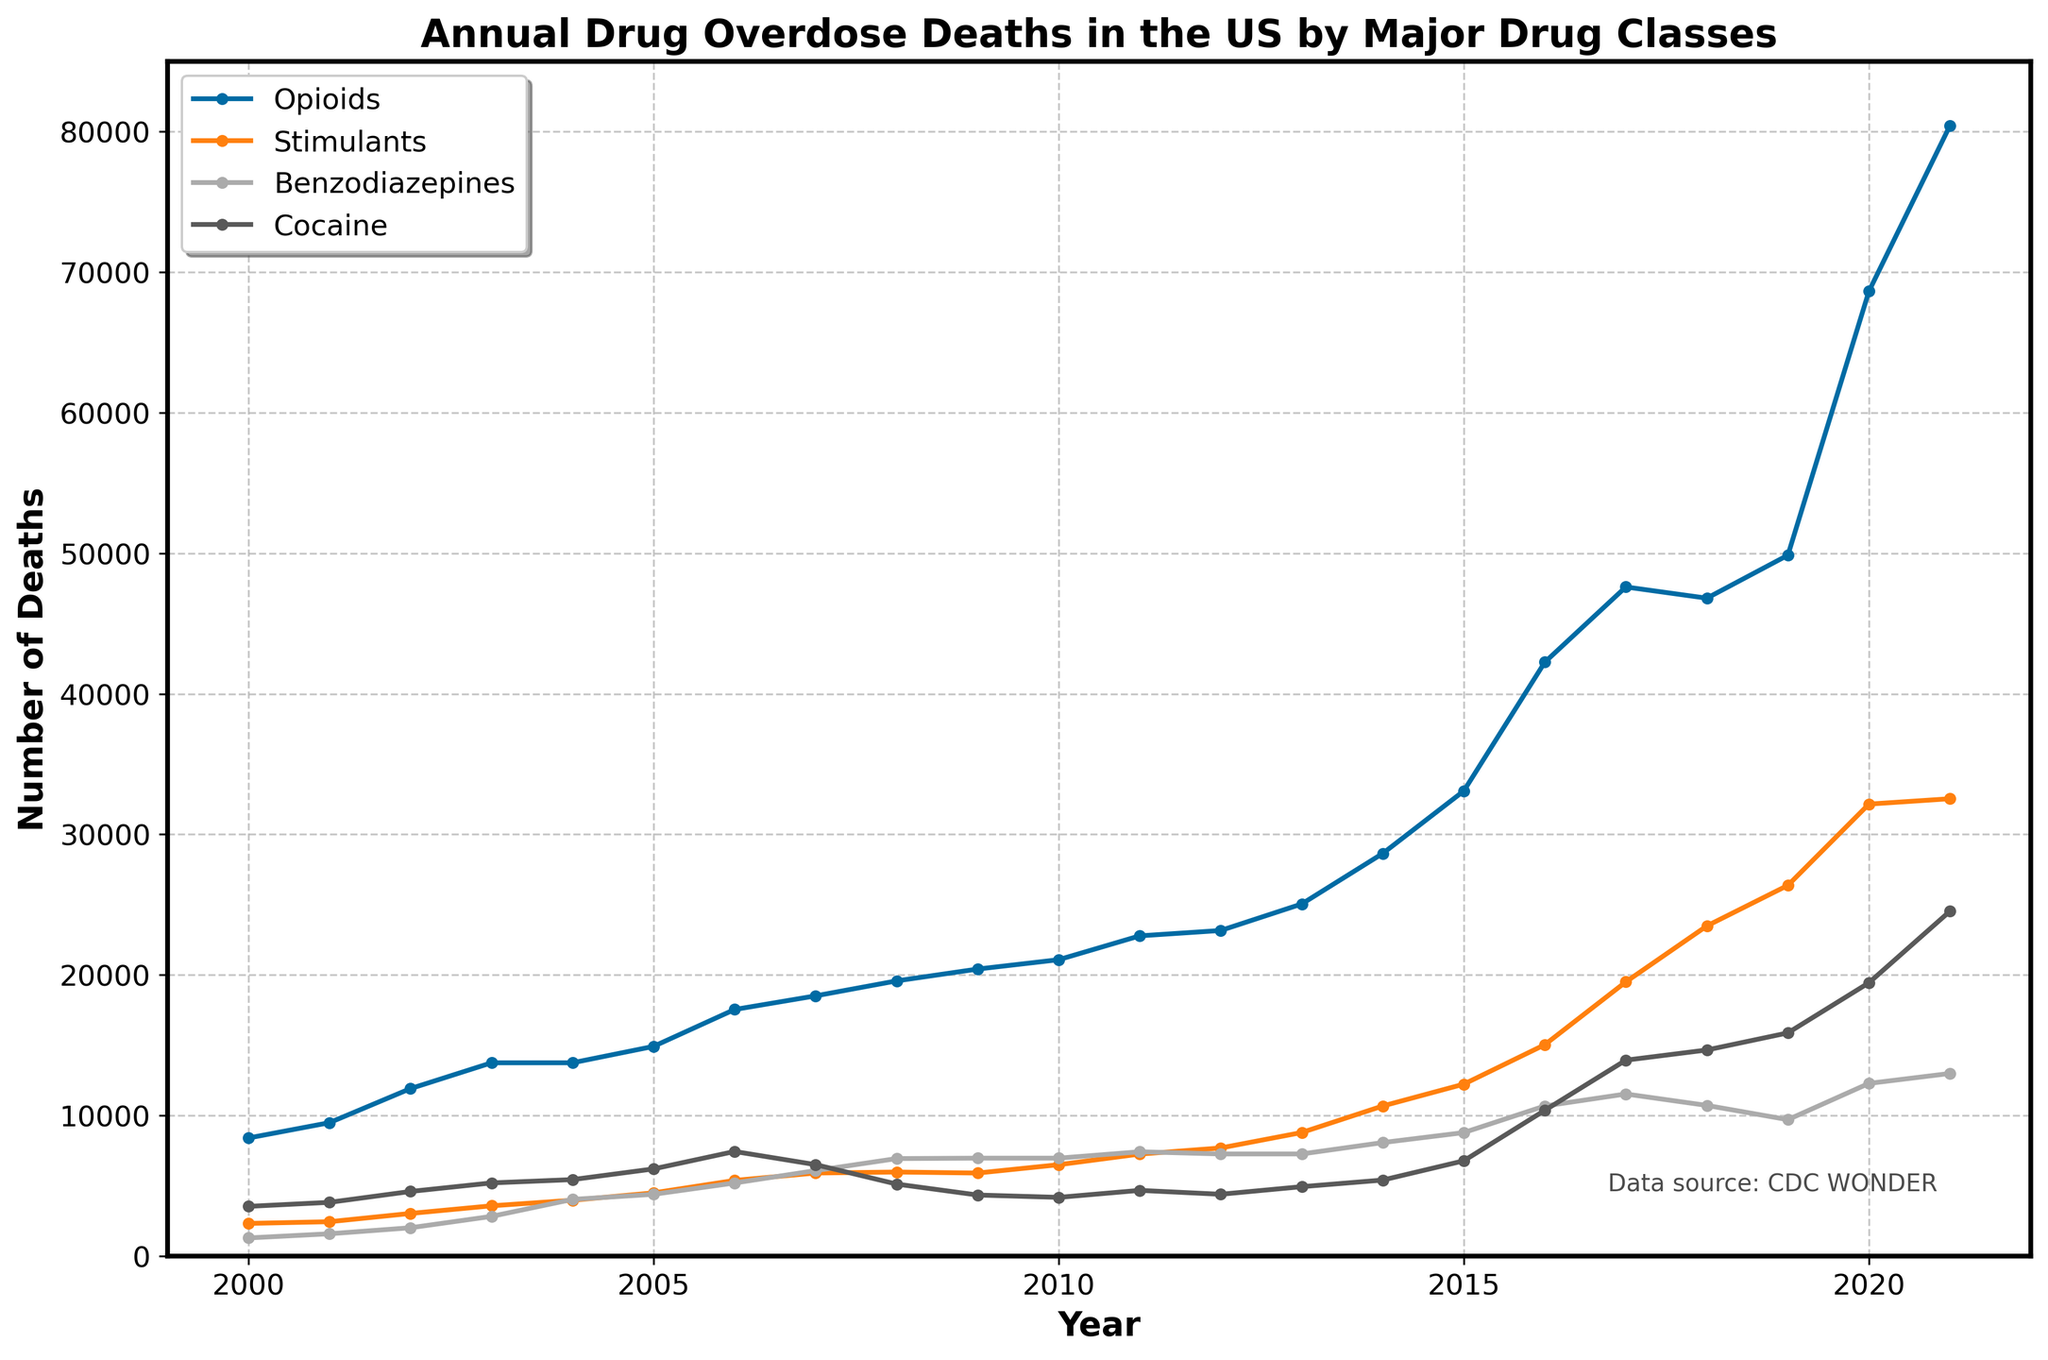What was the trend in opioid overdose deaths from 2000 to 2021? Observing the line representing opioid overdose deaths, there is a general increasing trend throughout the years from 2000 to 2021 with noticeable surges around 2015-2016 and 2019-2020.
Answer: Increasing Which drug class had the highest number of overdose deaths in 2021? Looking at the endpoints of each line at the year 2021, the line for opioids is noticeably higher than all other drug classes.
Answer: Opioids How did stimulant overdose deaths compare to benzodiazepine overdose deaths in 2015? By referencing the lines at the year 2015, the stimulant overdose deaths were at 12,236, while benzodiazepine overdose deaths were at 8,791. Thus, stimulants had higher deaths than benzodiazepines.
Answer: Stimulants had higher deaths What is the average annual increase in cocaine overdose deaths from 2015 to 2021? Calculate the deaths in 2021 (24,538) and 2015 (6,784), then find the difference (24,538 - 6,784 = 17,754). Divide this by the number of years (2021 - 2015 = 6): average increase = 17,754 / 6 ≈ 2,959.
Answer: 2,959 Which year did benzodiazepine overdose deaths peak? By observing the highest point along the benzodiazepine line, it peaks at 12,997 in the year 2021.
Answer: 2021 How did opioid overdose deaths in 2000 compare to those in 2010? Refer to the opioid line data points for 2000 and 2010. In 2000, deaths were 8,407 and in 2010, they were 21,088. Thus, there was a significant increase.
Answer: Increased What was the percentage increase in opioid overdose deaths from 2019 to 2020? Opioid deaths in 2019 were 49,860 and increased to 68,630 in 2020. Calculate the difference (68,630 - 49,860 = 18,770). Then, (18,770 / 49,860) * 100 ≈ 37.6%.
Answer: 37.6% How many more overdose deaths were there from stimulants in 2021 compared to 2018? In 2021, stimulant deaths were 32,537, while in 2018, they were 23,491. Subtracting the two gives 32,537 - 23,491 = 9,046.
Answer: 9,046 Which drug class showed the most consistent year-over-year increase from 2000 to 2021? By examining the lines' slopes, the opioid line consistently increases each year without any noticeable dips or flat periods, indicating the most consistent rise.
Answer: Opioids 